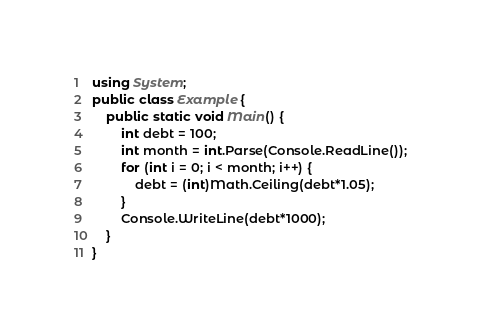<code> <loc_0><loc_0><loc_500><loc_500><_C#_>using System;
public class Example {
    public static void Main() {
        int debt = 100;
        int month = int.Parse(Console.ReadLine());
        for (int i = 0; i < month; i++) {
            debt = (int)Math.Ceiling(debt*1.05);
        }
        Console.WriteLine(debt*1000);
    }
}</code> 